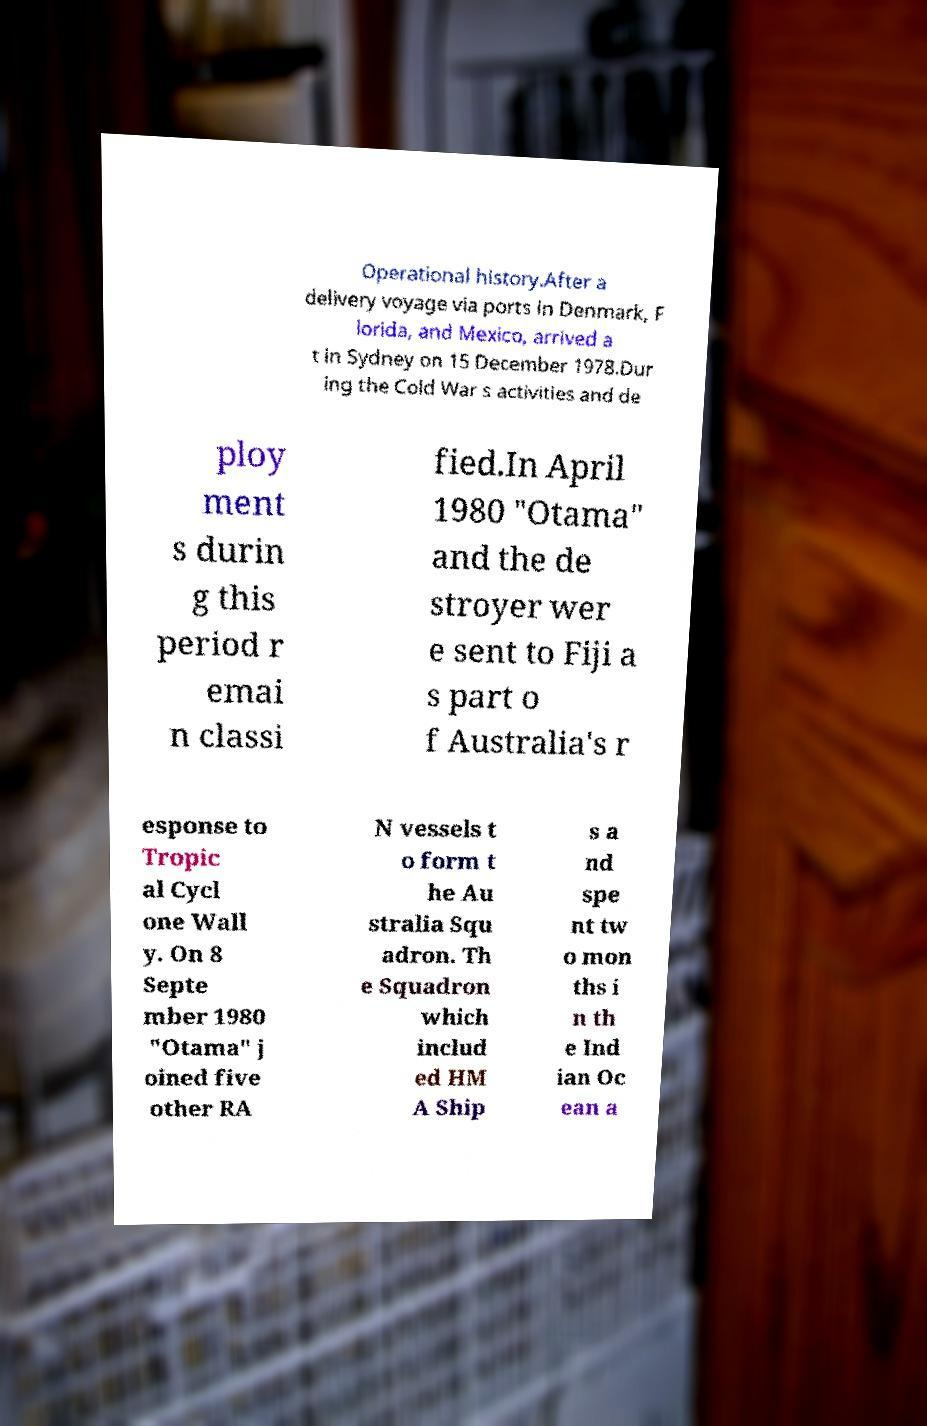What messages or text are displayed in this image? I need them in a readable, typed format. Operational history.After a delivery voyage via ports in Denmark, F lorida, and Mexico, arrived a t in Sydney on 15 December 1978.Dur ing the Cold War s activities and de ploy ment s durin g this period r emai n classi fied.In April 1980 "Otama" and the de stroyer wer e sent to Fiji a s part o f Australia's r esponse to Tropic al Cycl one Wall y. On 8 Septe mber 1980 "Otama" j oined five other RA N vessels t o form t he Au stralia Squ adron. Th e Squadron which includ ed HM A Ship s a nd spe nt tw o mon ths i n th e Ind ian Oc ean a 